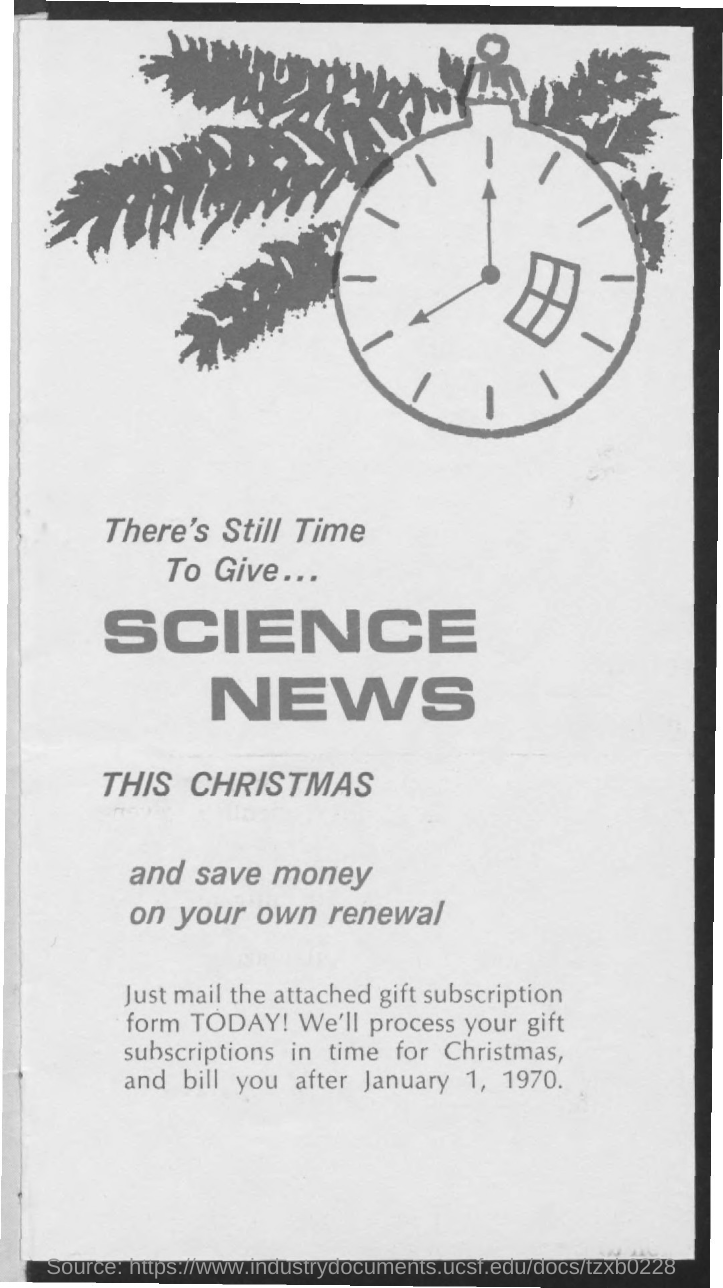What is the date mentioned in the document?
Provide a succinct answer. January 1, 1970. 